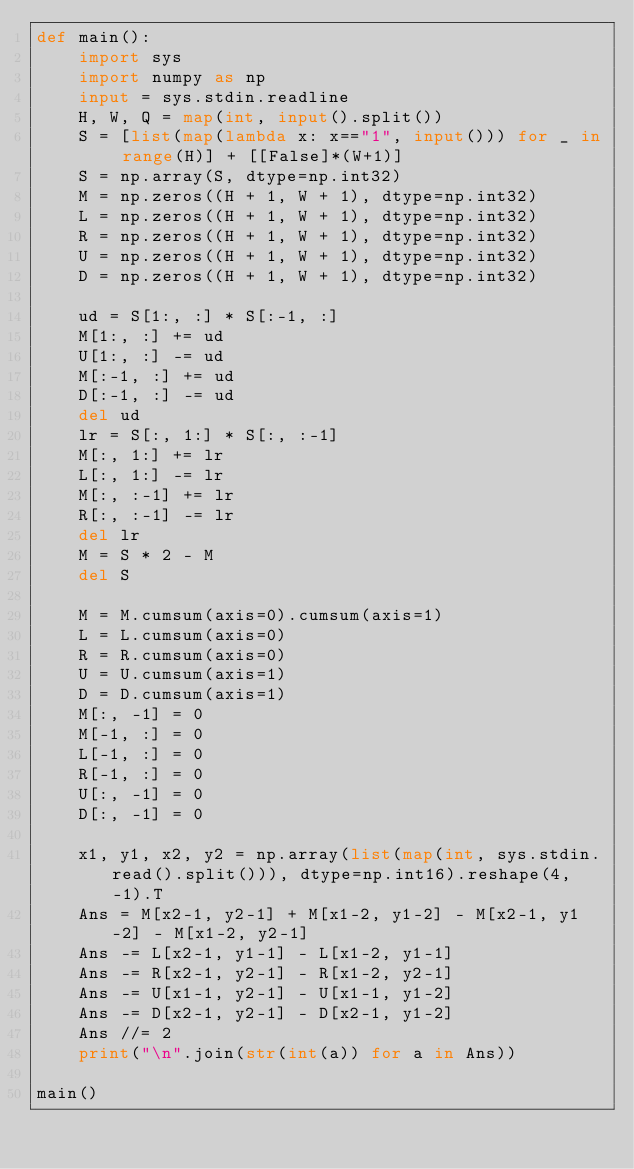<code> <loc_0><loc_0><loc_500><loc_500><_Python_>def main():
    import sys
    import numpy as np
    input = sys.stdin.readline
    H, W, Q = map(int, input().split())
    S = [list(map(lambda x: x=="1", input())) for _ in range(H)] + [[False]*(W+1)]
    S = np.array(S, dtype=np.int32)
    M = np.zeros((H + 1, W + 1), dtype=np.int32)
    L = np.zeros((H + 1, W + 1), dtype=np.int32)
    R = np.zeros((H + 1, W + 1), dtype=np.int32)
    U = np.zeros((H + 1, W + 1), dtype=np.int32)
    D = np.zeros((H + 1, W + 1), dtype=np.int32)

    ud = S[1:, :] * S[:-1, :]
    M[1:, :] += ud
    U[1:, :] -= ud
    M[:-1, :] += ud
    D[:-1, :] -= ud
    del ud
    lr = S[:, 1:] * S[:, :-1]
    M[:, 1:] += lr
    L[:, 1:] -= lr
    M[:, :-1] += lr
    R[:, :-1] -= lr
    del lr
    M = S * 2 - M
    del S

    M = M.cumsum(axis=0).cumsum(axis=1)
    L = L.cumsum(axis=0)
    R = R.cumsum(axis=0)
    U = U.cumsum(axis=1)
    D = D.cumsum(axis=1)
    M[:, -1] = 0
    M[-1, :] = 0
    L[-1, :] = 0
    R[-1, :] = 0
    U[:, -1] = 0
    D[:, -1] = 0

    x1, y1, x2, y2 = np.array(list(map(int, sys.stdin.read().split())), dtype=np.int16).reshape(4, -1).T
    Ans = M[x2-1, y2-1] + M[x1-2, y1-2] - M[x2-1, y1-2] - M[x1-2, y2-1]
    Ans -= L[x2-1, y1-1] - L[x1-2, y1-1]
    Ans -= R[x2-1, y2-1] - R[x1-2, y2-1]
    Ans -= U[x1-1, y2-1] - U[x1-1, y1-2]
    Ans -= D[x2-1, y2-1] - D[x2-1, y1-2]
    Ans //= 2
    print("\n".join(str(int(a)) for a in Ans))

main()
</code> 